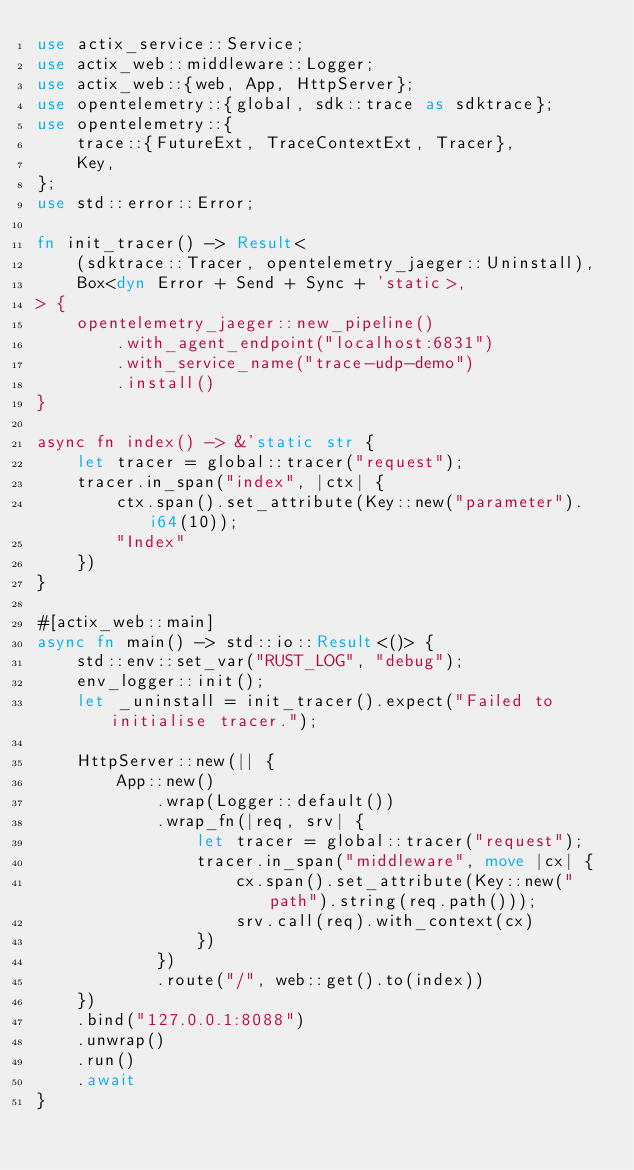Convert code to text. <code><loc_0><loc_0><loc_500><loc_500><_Rust_>use actix_service::Service;
use actix_web::middleware::Logger;
use actix_web::{web, App, HttpServer};
use opentelemetry::{global, sdk::trace as sdktrace};
use opentelemetry::{
    trace::{FutureExt, TraceContextExt, Tracer},
    Key,
};
use std::error::Error;

fn init_tracer() -> Result<
    (sdktrace::Tracer, opentelemetry_jaeger::Uninstall),
    Box<dyn Error + Send + Sync + 'static>,
> {
    opentelemetry_jaeger::new_pipeline()
        .with_agent_endpoint("localhost:6831")
        .with_service_name("trace-udp-demo")
        .install()
}

async fn index() -> &'static str {
    let tracer = global::tracer("request");
    tracer.in_span("index", |ctx| {
        ctx.span().set_attribute(Key::new("parameter").i64(10));
        "Index"
    })
}

#[actix_web::main]
async fn main() -> std::io::Result<()> {
    std::env::set_var("RUST_LOG", "debug");
    env_logger::init();
    let _uninstall = init_tracer().expect("Failed to initialise tracer.");

    HttpServer::new(|| {
        App::new()
            .wrap(Logger::default())
            .wrap_fn(|req, srv| {
                let tracer = global::tracer("request");
                tracer.in_span("middleware", move |cx| {
                    cx.span().set_attribute(Key::new("path").string(req.path()));
                    srv.call(req).with_context(cx)
                })
            })
            .route("/", web::get().to(index))
    })
    .bind("127.0.0.1:8088")
    .unwrap()
    .run()
    .await
}
</code> 